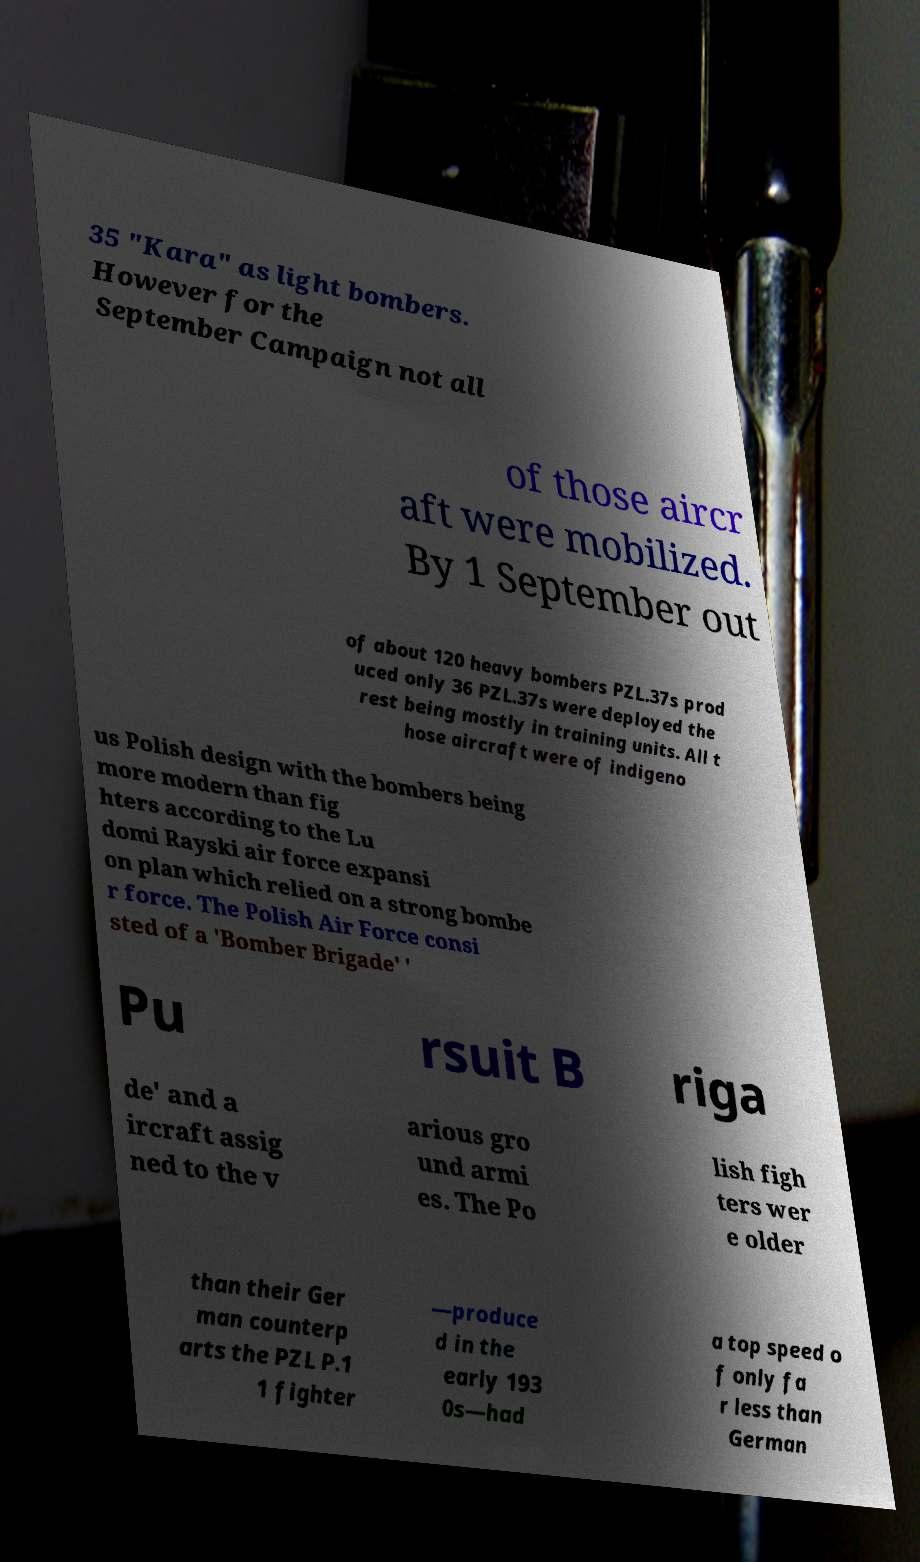Can you read and provide the text displayed in the image?This photo seems to have some interesting text. Can you extract and type it out for me? 35 "Kara" as light bombers. However for the September Campaign not all of those aircr aft were mobilized. By 1 September out of about 120 heavy bombers PZL.37s prod uced only 36 PZL.37s were deployed the rest being mostly in training units. All t hose aircraft were of indigeno us Polish design with the bombers being more modern than fig hters according to the Lu domi Rayski air force expansi on plan which relied on a strong bombe r force. The Polish Air Force consi sted of a 'Bomber Brigade' ' Pu rsuit B riga de' and a ircraft assig ned to the v arious gro und armi es. The Po lish figh ters wer e older than their Ger man counterp arts the PZL P.1 1 fighter —produce d in the early 193 0s—had a top speed o f only fa r less than German 